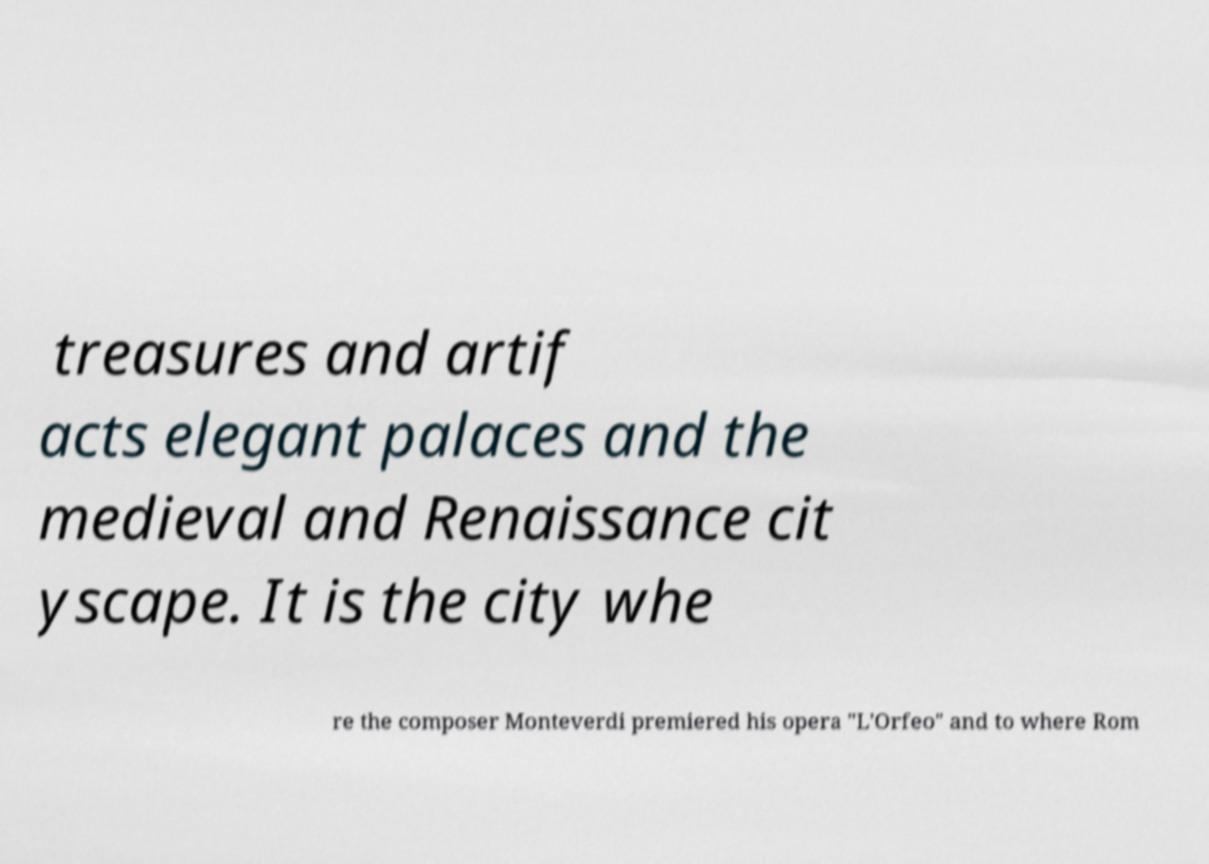Can you read and provide the text displayed in the image?This photo seems to have some interesting text. Can you extract and type it out for me? treasures and artif acts elegant palaces and the medieval and Renaissance cit yscape. It is the city whe re the composer Monteverdi premiered his opera "L'Orfeo" and to where Rom 